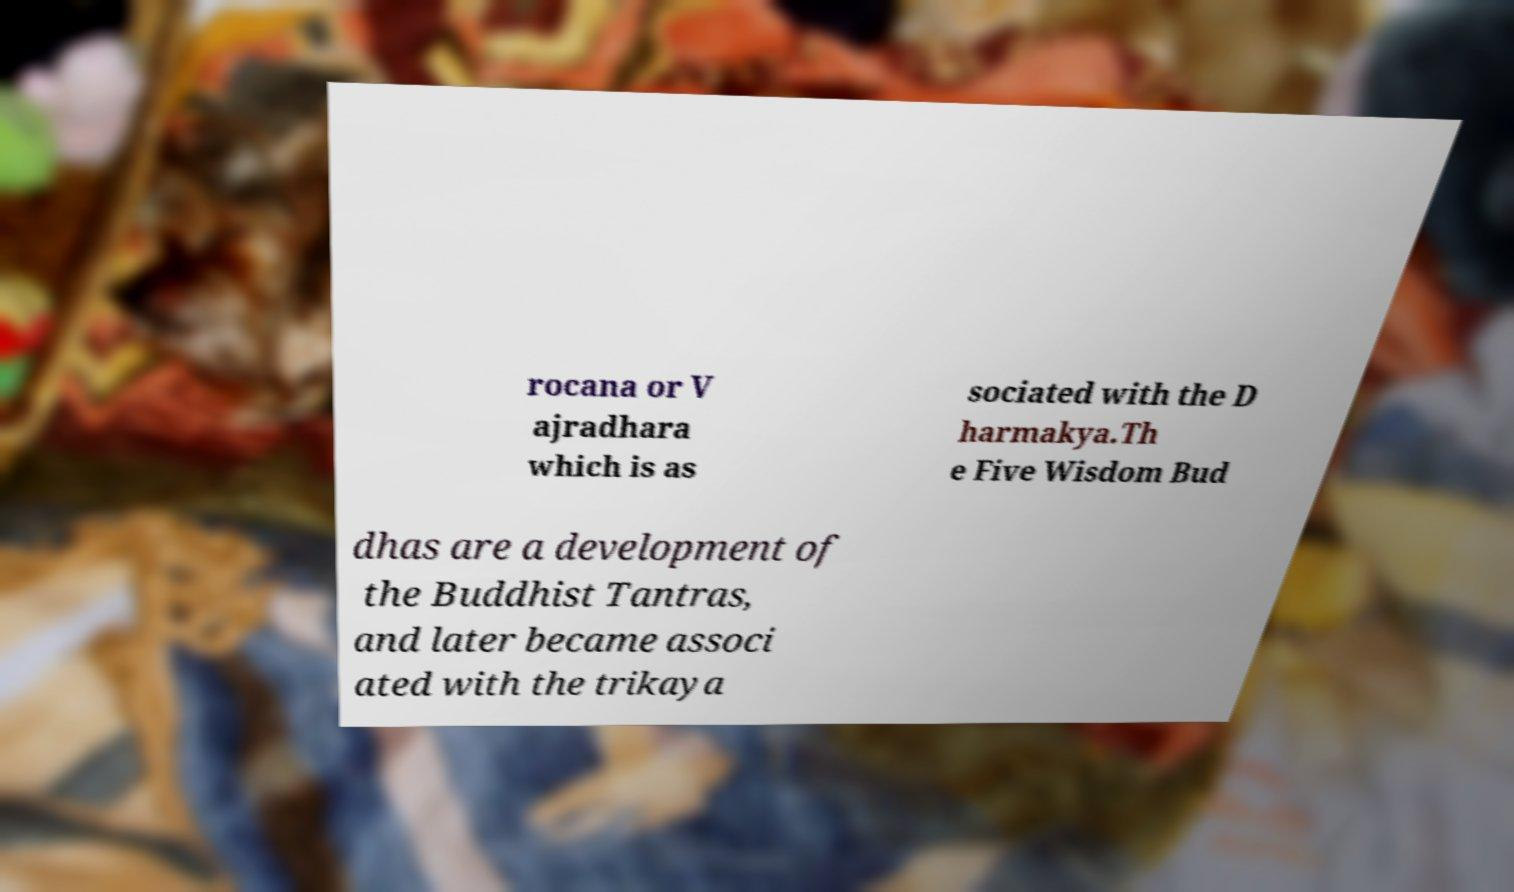Could you extract and type out the text from this image? rocana or V ajradhara which is as sociated with the D harmakya.Th e Five Wisdom Bud dhas are a development of the Buddhist Tantras, and later became associ ated with the trikaya 